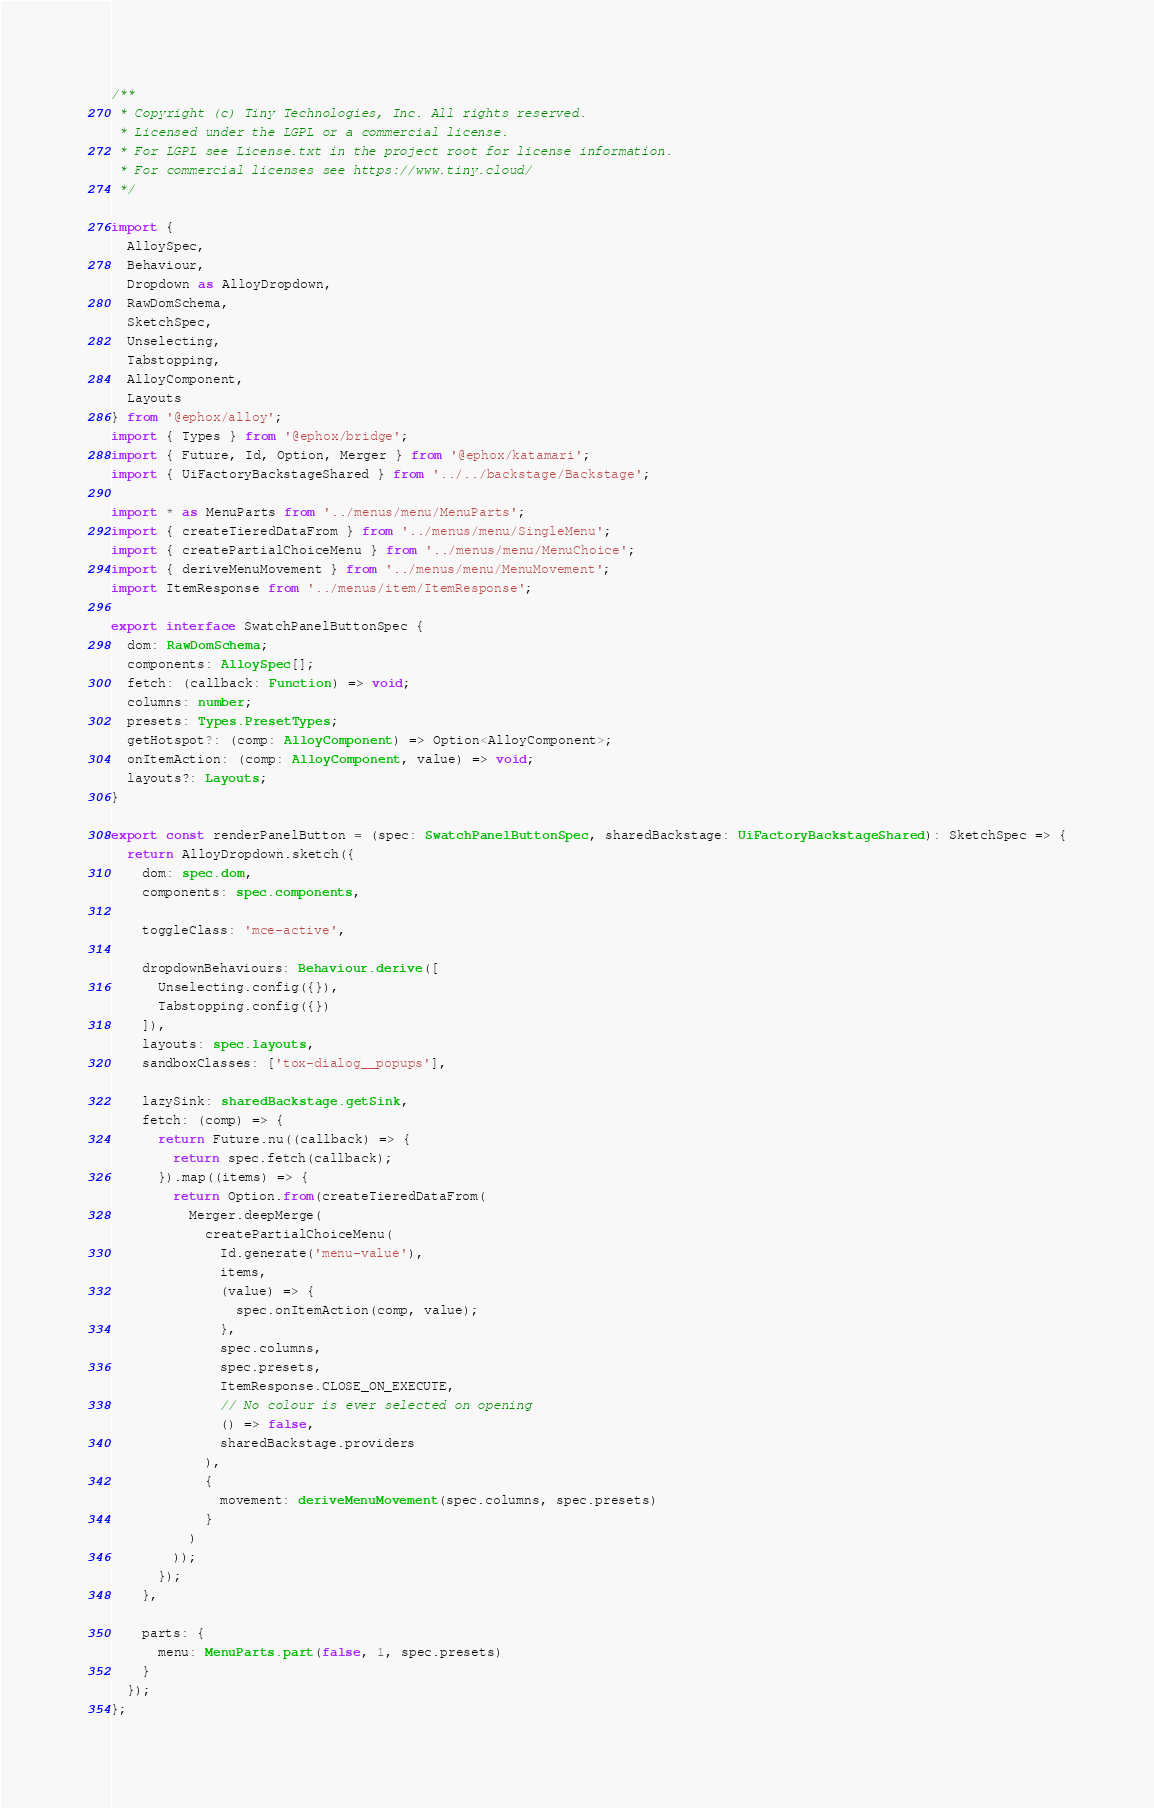<code> <loc_0><loc_0><loc_500><loc_500><_TypeScript_>/**
 * Copyright (c) Tiny Technologies, Inc. All rights reserved.
 * Licensed under the LGPL or a commercial license.
 * For LGPL see License.txt in the project root for license information.
 * For commercial licenses see https://www.tiny.cloud/
 */

import {
  AlloySpec,
  Behaviour,
  Dropdown as AlloyDropdown,
  RawDomSchema,
  SketchSpec,
  Unselecting,
  Tabstopping,
  AlloyComponent,
  Layouts
} from '@ephox/alloy';
import { Types } from '@ephox/bridge';
import { Future, Id, Option, Merger } from '@ephox/katamari';
import { UiFactoryBackstageShared } from '../../backstage/Backstage';

import * as MenuParts from '../menus/menu/MenuParts';
import { createTieredDataFrom } from '../menus/menu/SingleMenu';
import { createPartialChoiceMenu } from '../menus/menu/MenuChoice';
import { deriveMenuMovement } from '../menus/menu/MenuMovement';
import ItemResponse from '../menus/item/ItemResponse';

export interface SwatchPanelButtonSpec {
  dom: RawDomSchema;
  components: AlloySpec[];
  fetch: (callback: Function) => void;
  columns: number;
  presets: Types.PresetTypes;
  getHotspot?: (comp: AlloyComponent) => Option<AlloyComponent>;
  onItemAction: (comp: AlloyComponent, value) => void;
  layouts?: Layouts;
}

export const renderPanelButton = (spec: SwatchPanelButtonSpec, sharedBackstage: UiFactoryBackstageShared): SketchSpec => {
  return AlloyDropdown.sketch({
    dom: spec.dom,
    components: spec.components,

    toggleClass: 'mce-active',

    dropdownBehaviours: Behaviour.derive([
      Unselecting.config({}),
      Tabstopping.config({})
    ]),
    layouts: spec.layouts,
    sandboxClasses: ['tox-dialog__popups'],

    lazySink: sharedBackstage.getSink,
    fetch: (comp) => {
      return Future.nu((callback) => {
        return spec.fetch(callback);
      }).map((items) => {
        return Option.from(createTieredDataFrom(
          Merger.deepMerge(
            createPartialChoiceMenu(
              Id.generate('menu-value'),
              items,
              (value) => {
                spec.onItemAction(comp, value);
              },
              spec.columns,
              spec.presets,
              ItemResponse.CLOSE_ON_EXECUTE,
              // No colour is ever selected on opening
              () => false,
              sharedBackstage.providers
            ),
            {
              movement: deriveMenuMovement(spec.columns, spec.presets)
            }
          )
        ));
      });
    },

    parts: {
      menu: MenuParts.part(false, 1, spec.presets)
    }
  });
};</code> 